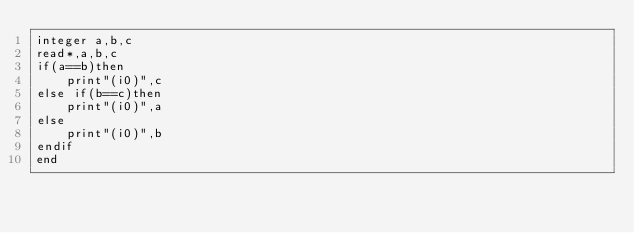Convert code to text. <code><loc_0><loc_0><loc_500><loc_500><_FORTRAN_>integer a,b,c
read*,a,b,c
if(a==b)then
	print"(i0)",c
else if(b==c)then
	print"(i0)",a
else
	print"(i0)",b
endif
end</code> 